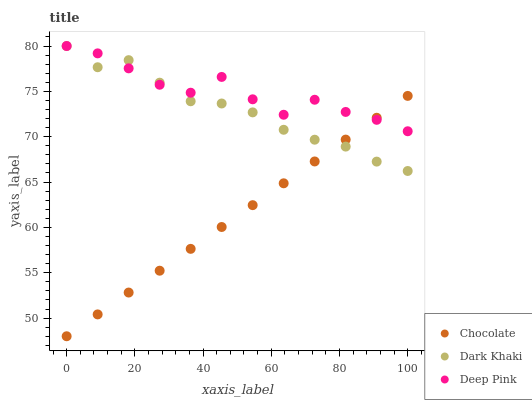Does Chocolate have the minimum area under the curve?
Answer yes or no. Yes. Does Deep Pink have the maximum area under the curve?
Answer yes or no. Yes. Does Deep Pink have the minimum area under the curve?
Answer yes or no. No. Does Chocolate have the maximum area under the curve?
Answer yes or no. No. Is Chocolate the smoothest?
Answer yes or no. Yes. Is Deep Pink the roughest?
Answer yes or no. Yes. Is Deep Pink the smoothest?
Answer yes or no. No. Is Chocolate the roughest?
Answer yes or no. No. Does Chocolate have the lowest value?
Answer yes or no. Yes. Does Deep Pink have the lowest value?
Answer yes or no. No. Does Deep Pink have the highest value?
Answer yes or no. Yes. Does Chocolate have the highest value?
Answer yes or no. No. Does Chocolate intersect Deep Pink?
Answer yes or no. Yes. Is Chocolate less than Deep Pink?
Answer yes or no. No. Is Chocolate greater than Deep Pink?
Answer yes or no. No. 